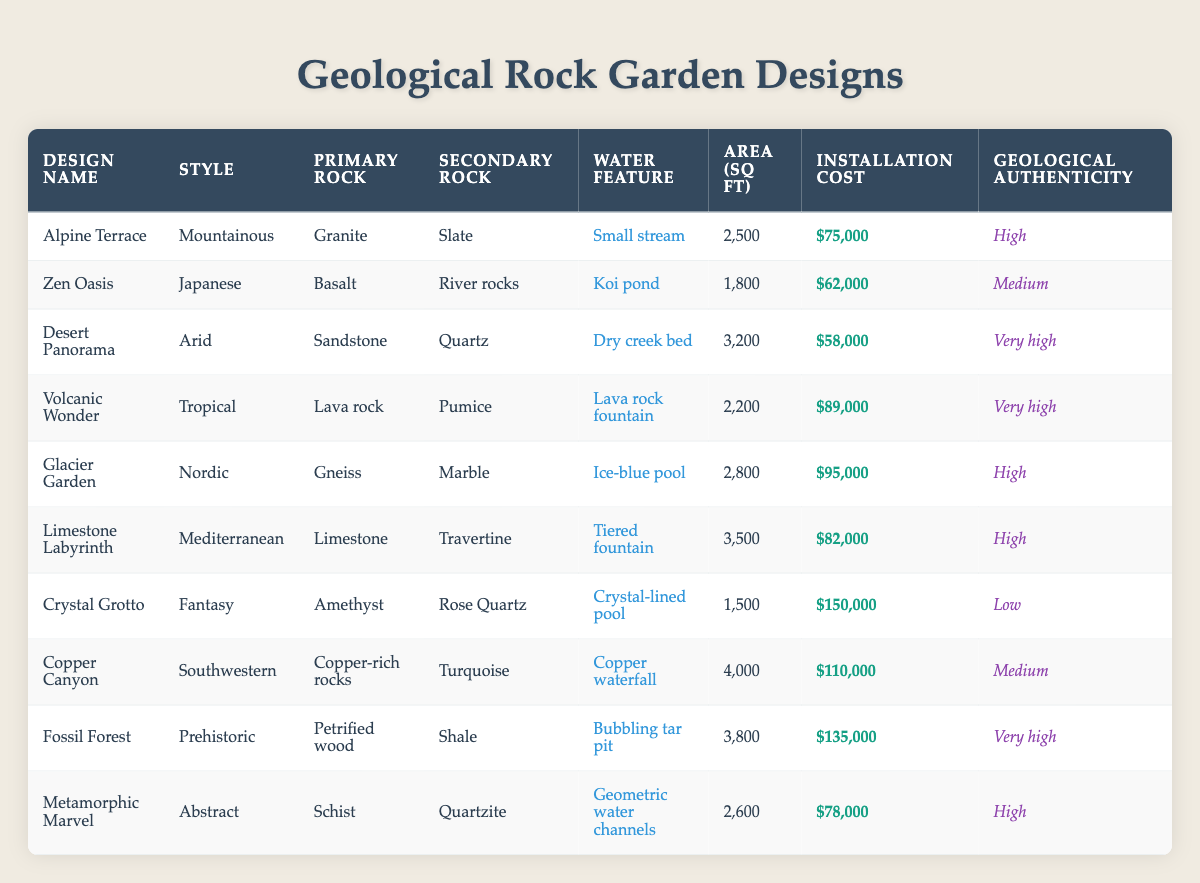What is the installation cost of the "Crystal Grotto" design? The installation cost of the "Crystal Grotto" design is highlighted in the table under the "Installation Cost" column, which shows $150,000.
Answer: $150,000 Which design has the highest geological authenticity? The "Desert Panorama," "Volcanic Wonder," and "Fossil Forest" designs each have a "Very high" geological authenticity rating, but "Fossil Forest" has the highest installation cost among them.
Answer: Fossil Forest Calculate the average installation cost of gardens with "Medium" maintenance level. The installation costs for designs with "Medium" maintenance level are Alpine Terrace ($75,000), Zen Oasis ($62,000), Glacier Garden ($95,000), Limestone Labyrinth ($82,000), and Metamorphic Marvel ($78,000). The total cost = 75,000 + 62,000 + 95,000 + 82,000 + 78,000 = 392,000. Average = 392,000 / 5 = 78,400.
Answer: $78,400 Does the "Alpine Terrace" design have a low plant density? Looking at the "Plant Density" column for the "Alpine Terrace" design, it shows "Low." Therefore, the answer is true.
Answer: Yes What is the total area of the "Copper Canyon" and "Fossil Forest" designs? The areas for "Copper Canyon" and "Fossil Forest" designs are listed as 4,000 sq ft and 3,800 sq ft, respectively. Adding these gives a total area of 4,000 + 3,800 = 7,800 sq ft.
Answer: 7,800 sq ft Which design has the smallest area and installation cost combined? The "Zen Oasis" design has an area of 1,800 sq ft and an installation cost of $62,000, totaling 63,800. Checking all designs indicates this is the lowest total.
Answer: Zen Oasis Is there any design with a "High" geological authenticity and a "High" maintenance level? Upon reviewing the table, the designs with "High" geological authenticity include Alpine Terrace, Glacier Garden, Limestone Labyrinth, and Metamorphic Marvel. The maintenance levels for these are Medium or Low. Hence, no designs meet both criteria.
Answer: No What water feature does the "Metamorphic Marvel" design have? The water feature for the "Metamorphic Marvel" design is listed in the table as "Geometric water channels." This can be found under the "Water Feature" column.
Answer: Geometric water channels 